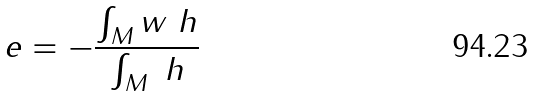<formula> <loc_0><loc_0><loc_500><loc_500>\ e = - \frac { \int _ { M } w \ h } { \int _ { M } \ h }</formula> 